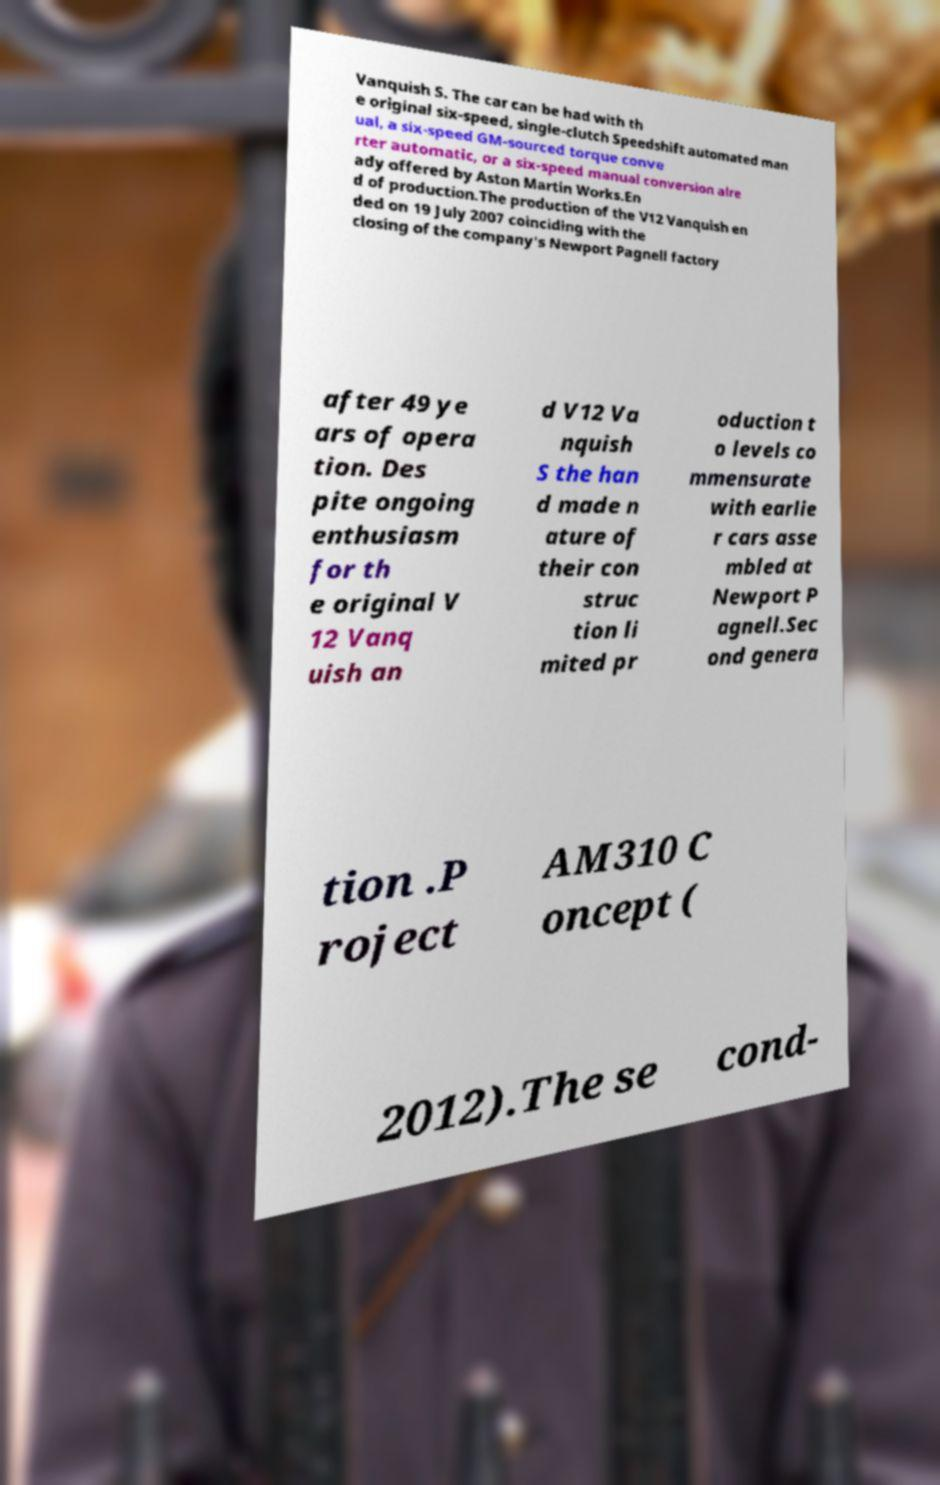Can you read and provide the text displayed in the image?This photo seems to have some interesting text. Can you extract and type it out for me? Vanquish S. The car can be had with th e original six-speed, single-clutch Speedshift automated man ual, a six-speed GM-sourced torque conve rter automatic, or a six-speed manual conversion alre ady offered by Aston Martin Works.En d of production.The production of the V12 Vanquish en ded on 19 July 2007 coinciding with the closing of the company's Newport Pagnell factory after 49 ye ars of opera tion. Des pite ongoing enthusiasm for th e original V 12 Vanq uish an d V12 Va nquish S the han d made n ature of their con struc tion li mited pr oduction t o levels co mmensurate with earlie r cars asse mbled at Newport P agnell.Sec ond genera tion .P roject AM310 C oncept ( 2012).The se cond- 